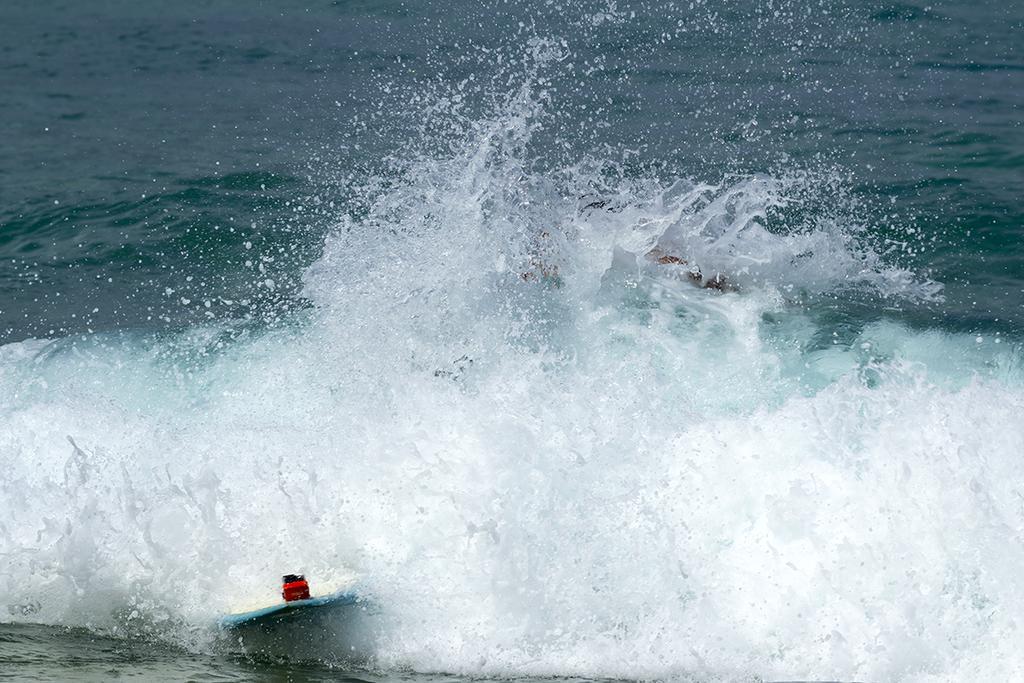Could you give a brief overview of what you see in this image? In the image in the center, we can see water and boats. 